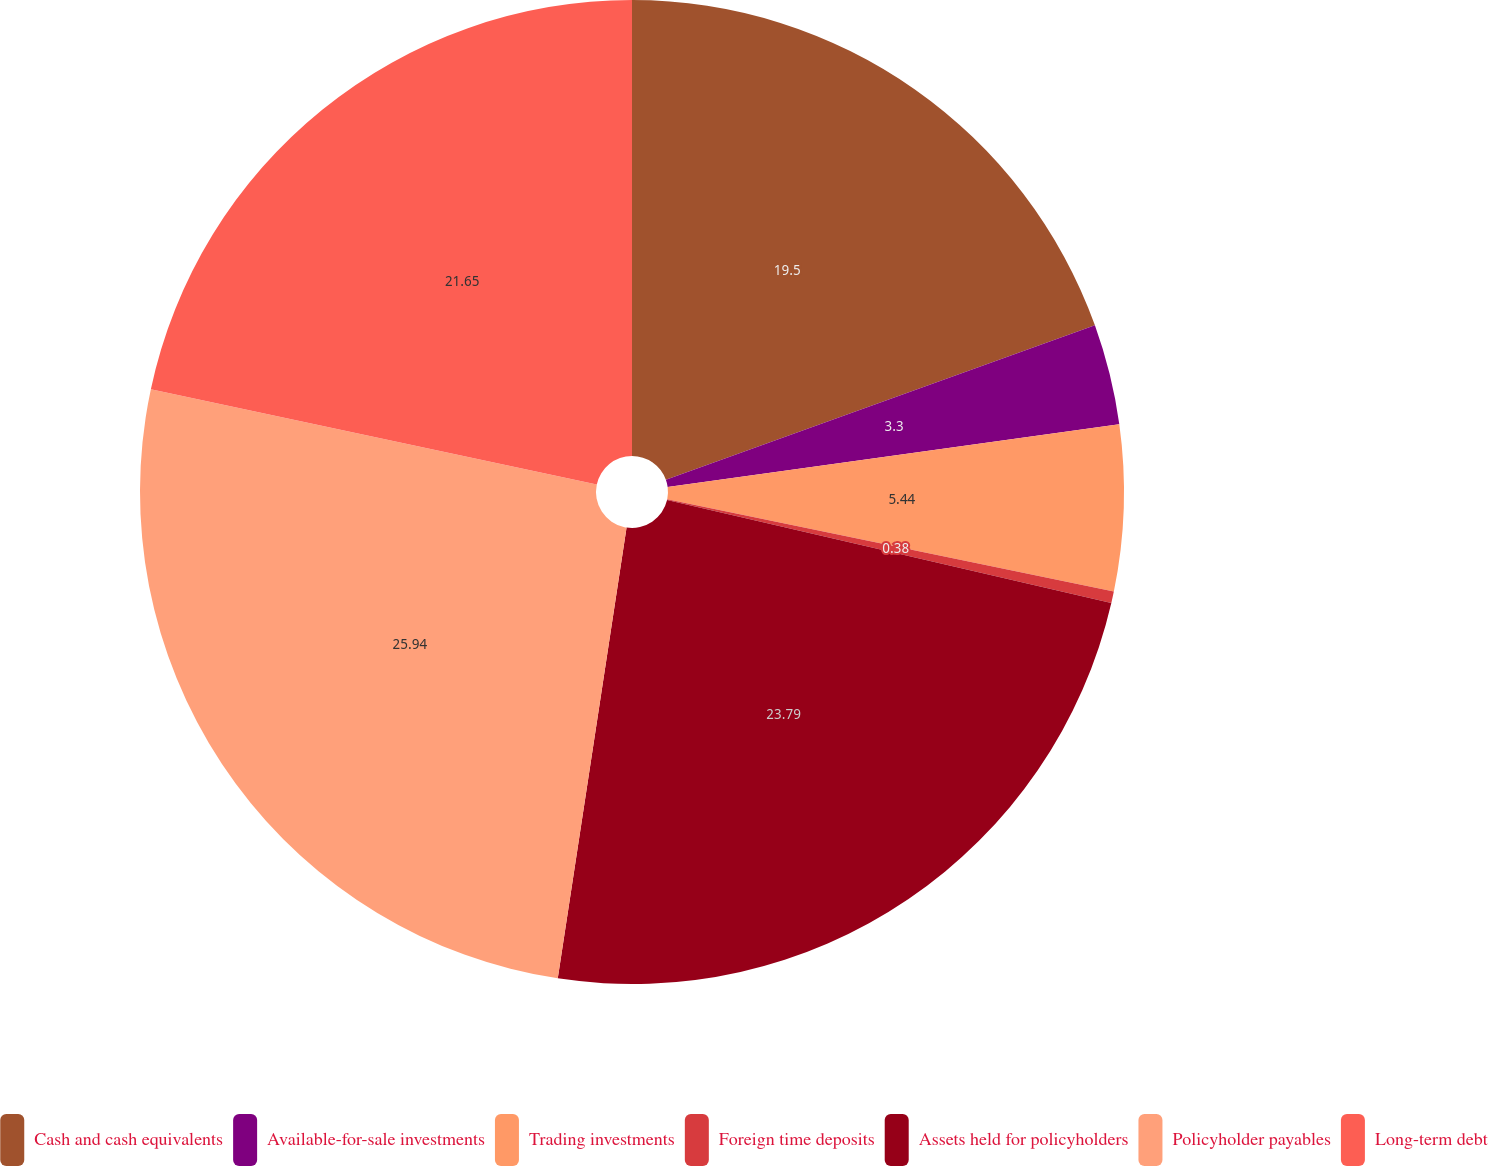Convert chart to OTSL. <chart><loc_0><loc_0><loc_500><loc_500><pie_chart><fcel>Cash and cash equivalents<fcel>Available-for-sale investments<fcel>Trading investments<fcel>Foreign time deposits<fcel>Assets held for policyholders<fcel>Policyholder payables<fcel>Long-term debt<nl><fcel>19.5%<fcel>3.3%<fcel>5.44%<fcel>0.38%<fcel>23.79%<fcel>25.94%<fcel>21.65%<nl></chart> 